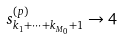Convert formula to latex. <formula><loc_0><loc_0><loc_500><loc_500>s ^ { ( p ) } _ { k _ { 1 } + \dots + k _ { M _ { 0 } } + 1 } \to 4</formula> 